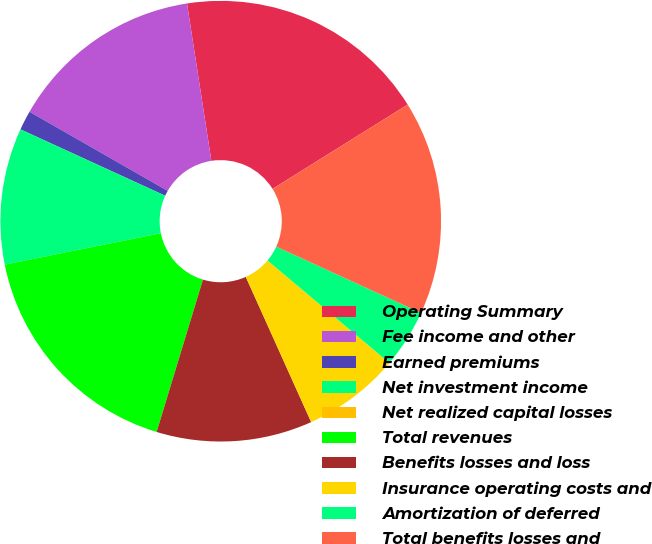<chart> <loc_0><loc_0><loc_500><loc_500><pie_chart><fcel>Operating Summary<fcel>Fee income and other<fcel>Earned premiums<fcel>Net investment income<fcel>Net realized capital losses<fcel>Total revenues<fcel>Benefits losses and loss<fcel>Insurance operating costs and<fcel>Amortization of deferred<fcel>Total benefits losses and<nl><fcel>18.57%<fcel>14.28%<fcel>1.43%<fcel>10.0%<fcel>0.0%<fcel>17.14%<fcel>11.43%<fcel>7.14%<fcel>4.29%<fcel>15.71%<nl></chart> 